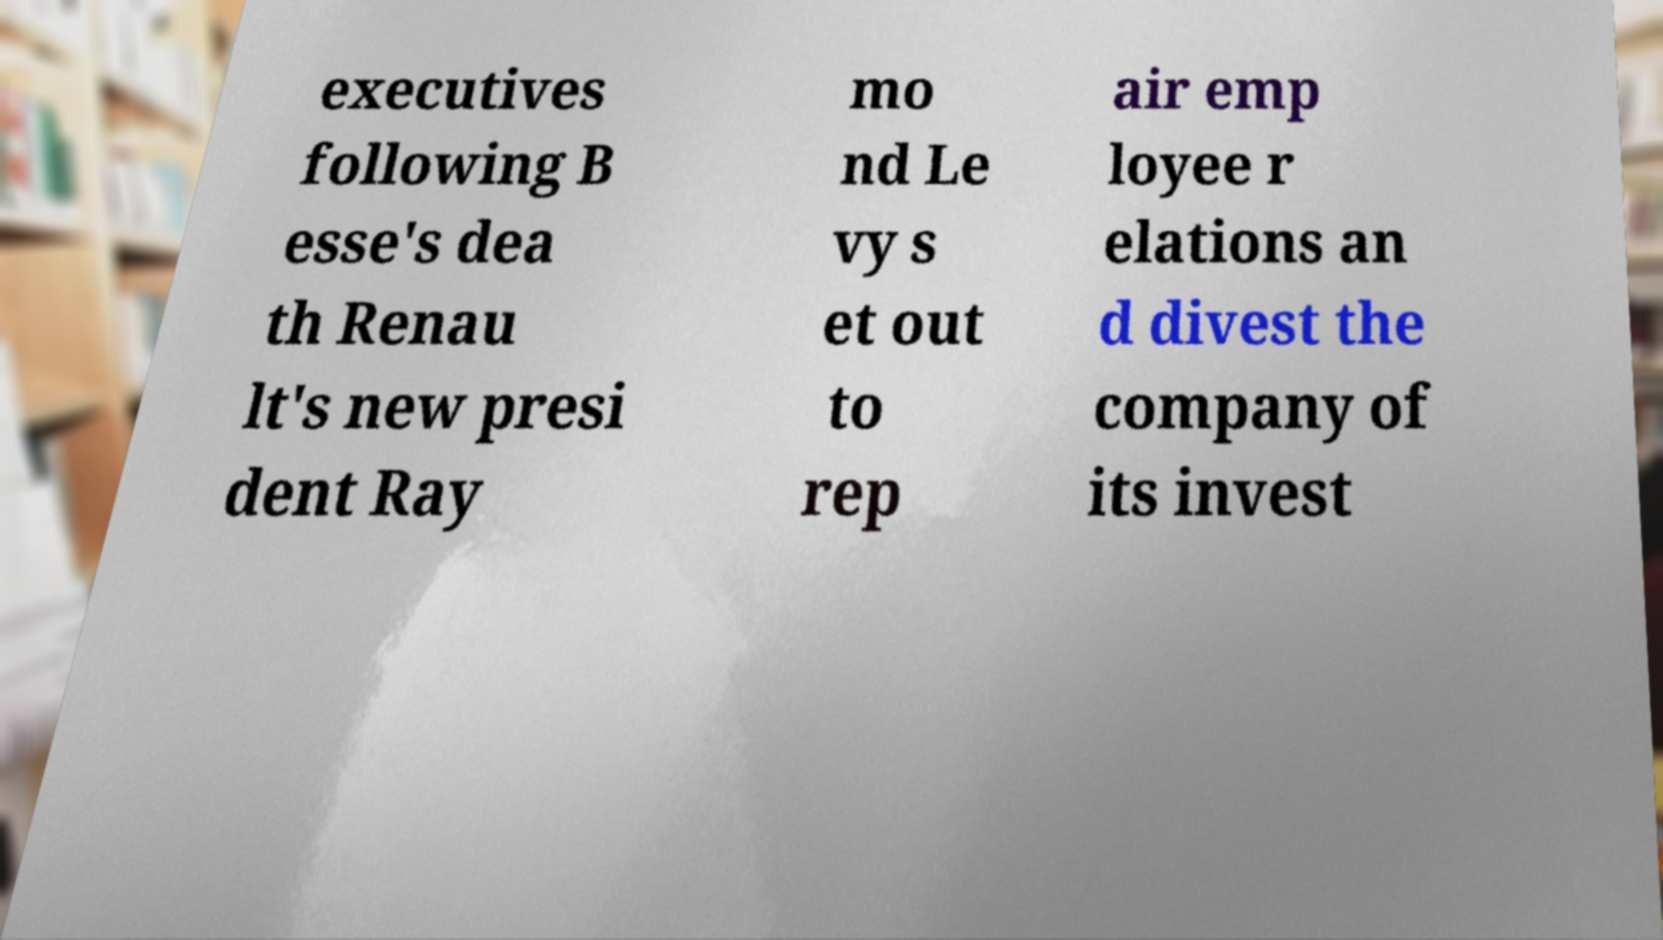Please read and relay the text visible in this image. What does it say? executives following B esse's dea th Renau lt's new presi dent Ray mo nd Le vy s et out to rep air emp loyee r elations an d divest the company of its invest 